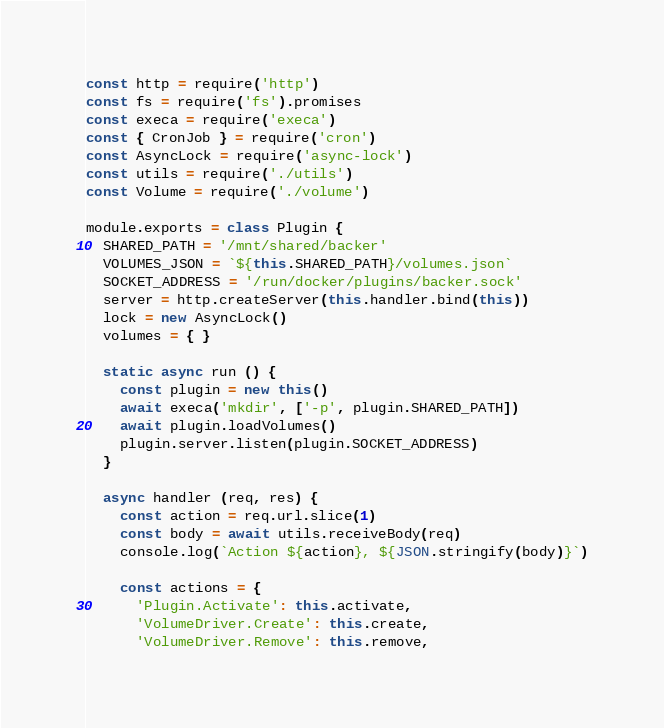<code> <loc_0><loc_0><loc_500><loc_500><_JavaScript_>const http = require('http')
const fs = require('fs').promises
const execa = require('execa')
const { CronJob } = require('cron')
const AsyncLock = require('async-lock')
const utils = require('./utils')
const Volume = require('./volume')

module.exports = class Plugin {
  SHARED_PATH = '/mnt/shared/backer'
  VOLUMES_JSON = `${this.SHARED_PATH}/volumes.json`
  SOCKET_ADDRESS = '/run/docker/plugins/backer.sock'
  server = http.createServer(this.handler.bind(this))
  lock = new AsyncLock()
  volumes = { }

  static async run () {
    const plugin = new this()
    await execa('mkdir', ['-p', plugin.SHARED_PATH])
    await plugin.loadVolumes()
    plugin.server.listen(plugin.SOCKET_ADDRESS)
  }

  async handler (req, res) {
    const action = req.url.slice(1)
    const body = await utils.receiveBody(req)
    console.log(`Action ${action}, ${JSON.stringify(body)}`)

    const actions = {
      'Plugin.Activate': this.activate,
      'VolumeDriver.Create': this.create,
      'VolumeDriver.Remove': this.remove,</code> 